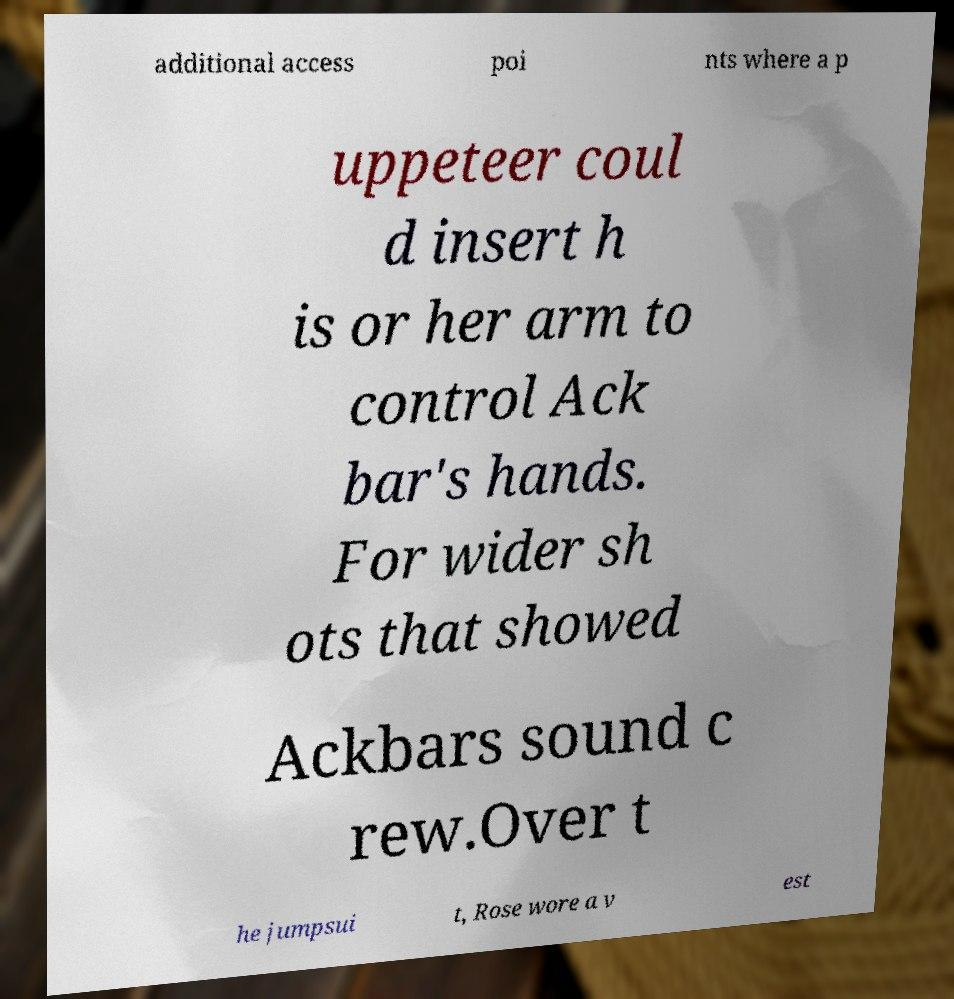What messages or text are displayed in this image? I need them in a readable, typed format. additional access poi nts where a p uppeteer coul d insert h is or her arm to control Ack bar's hands. For wider sh ots that showed Ackbars sound c rew.Over t he jumpsui t, Rose wore a v est 